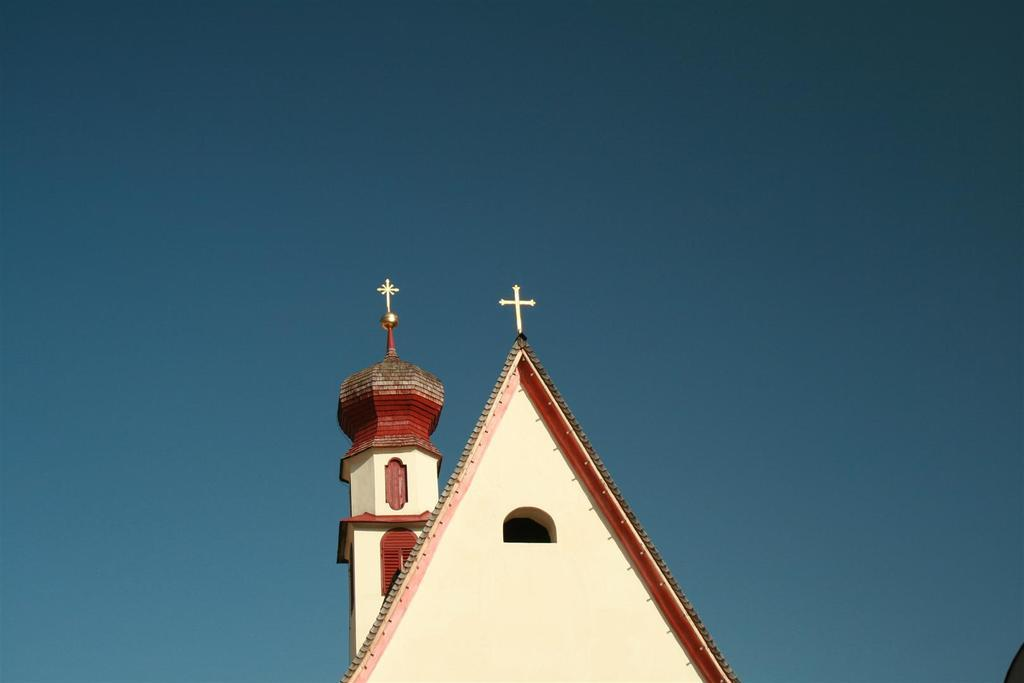What type of building is shown from a top view in the image? The image shows a top view of a church. What can be seen in the background of the image? The sky is visible in the background of the image. How many ants can be seen crawling on the stone walls of the church in the image? There are no ants visible on the church walls in the image. Is there a camp set up near the church in the image? There is no camp visible near the church in the image. 